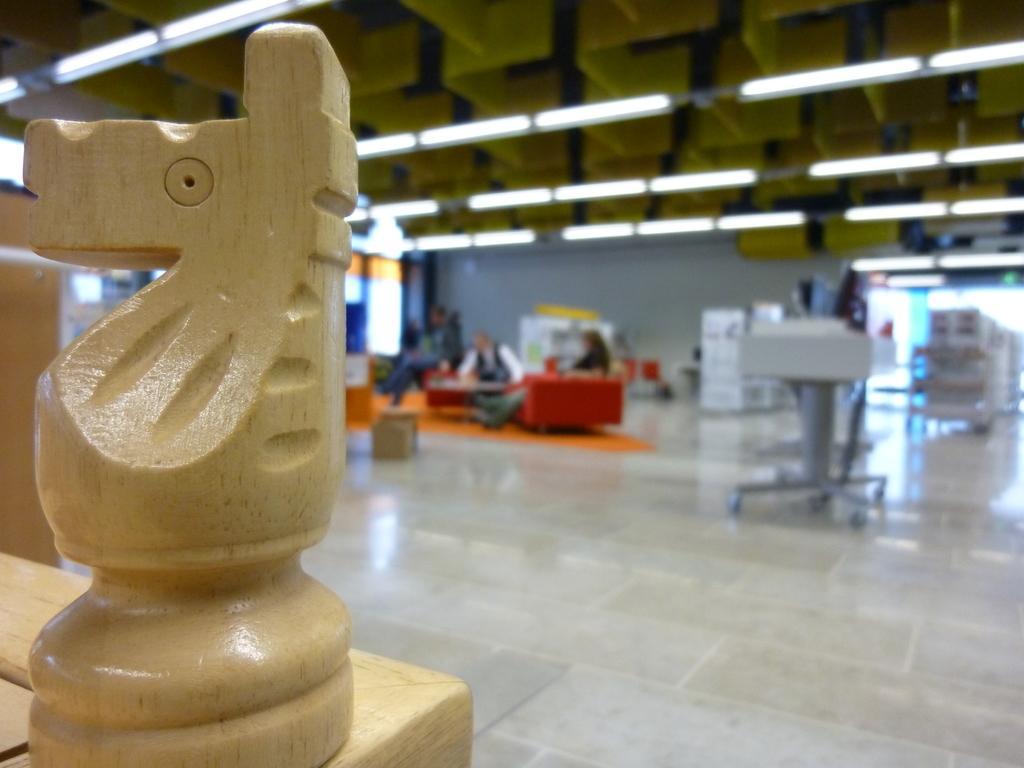How would you summarize this image in a sentence or two? We can see wooden object on the table. In the background it is blurry and we can see floor,people and objects. Top we can see lights. 